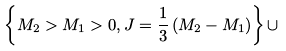Convert formula to latex. <formula><loc_0><loc_0><loc_500><loc_500>\left \{ M _ { 2 } > M _ { 1 } > 0 , J = { \frac { 1 } { 3 } } \left ( M _ { 2 } - M _ { 1 } \right ) \right \} \cup</formula> 